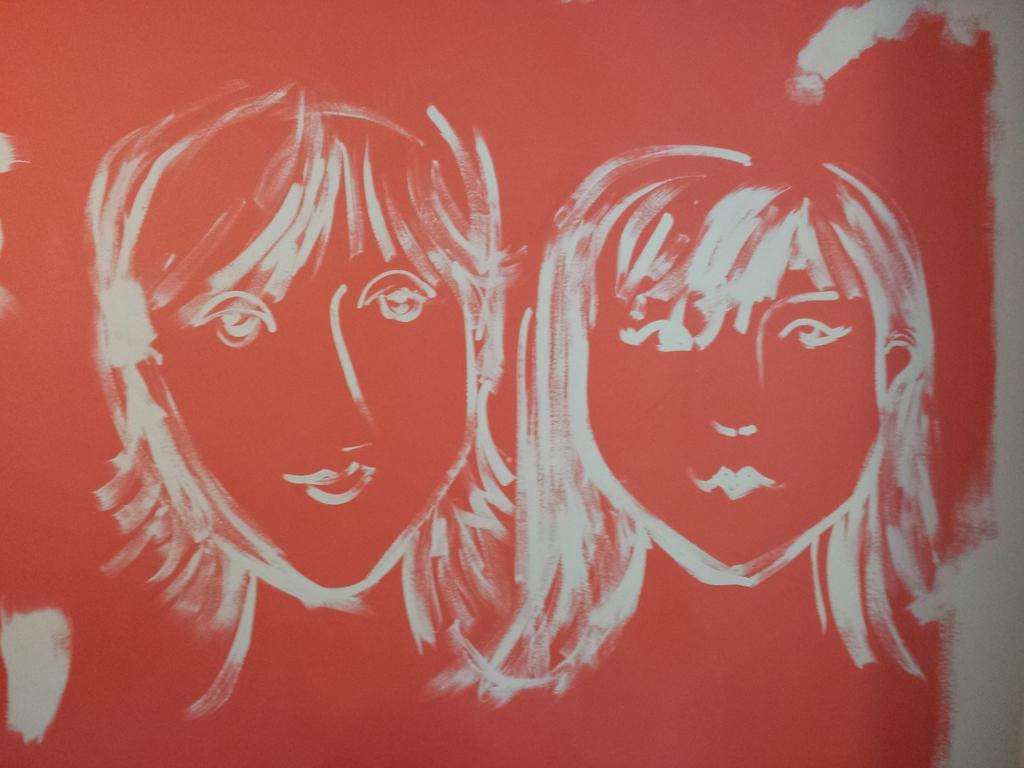What is hanging on the wall in the image? There is a painting on the wall in the image. How far away is the lake from the painting in the image? There is no lake present in the image, so it is not possible to determine the distance between the painting and a lake. 